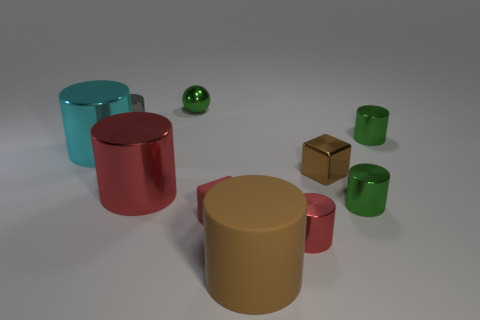Subtract all red cylinders. How many cylinders are left? 5 Subtract all green cubes. How many green cylinders are left? 2 Subtract 4 cylinders. How many cylinders are left? 3 Subtract all red cylinders. How many cylinders are left? 5 Subtract all cylinders. How many objects are left? 3 Add 9 cyan metal things. How many cyan metal things are left? 10 Add 2 tiny green shiny spheres. How many tiny green shiny spheres exist? 3 Subtract 1 brown cylinders. How many objects are left? 9 Subtract all red cylinders. Subtract all green blocks. How many cylinders are left? 5 Subtract all tiny red objects. Subtract all tiny green objects. How many objects are left? 5 